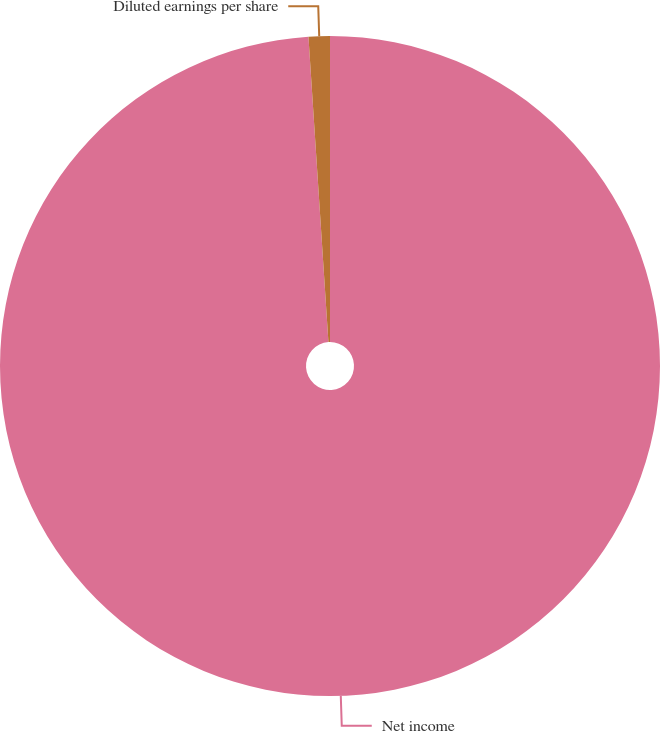Convert chart. <chart><loc_0><loc_0><loc_500><loc_500><pie_chart><fcel>Net income<fcel>Diluted earnings per share<nl><fcel>98.96%<fcel>1.04%<nl></chart> 